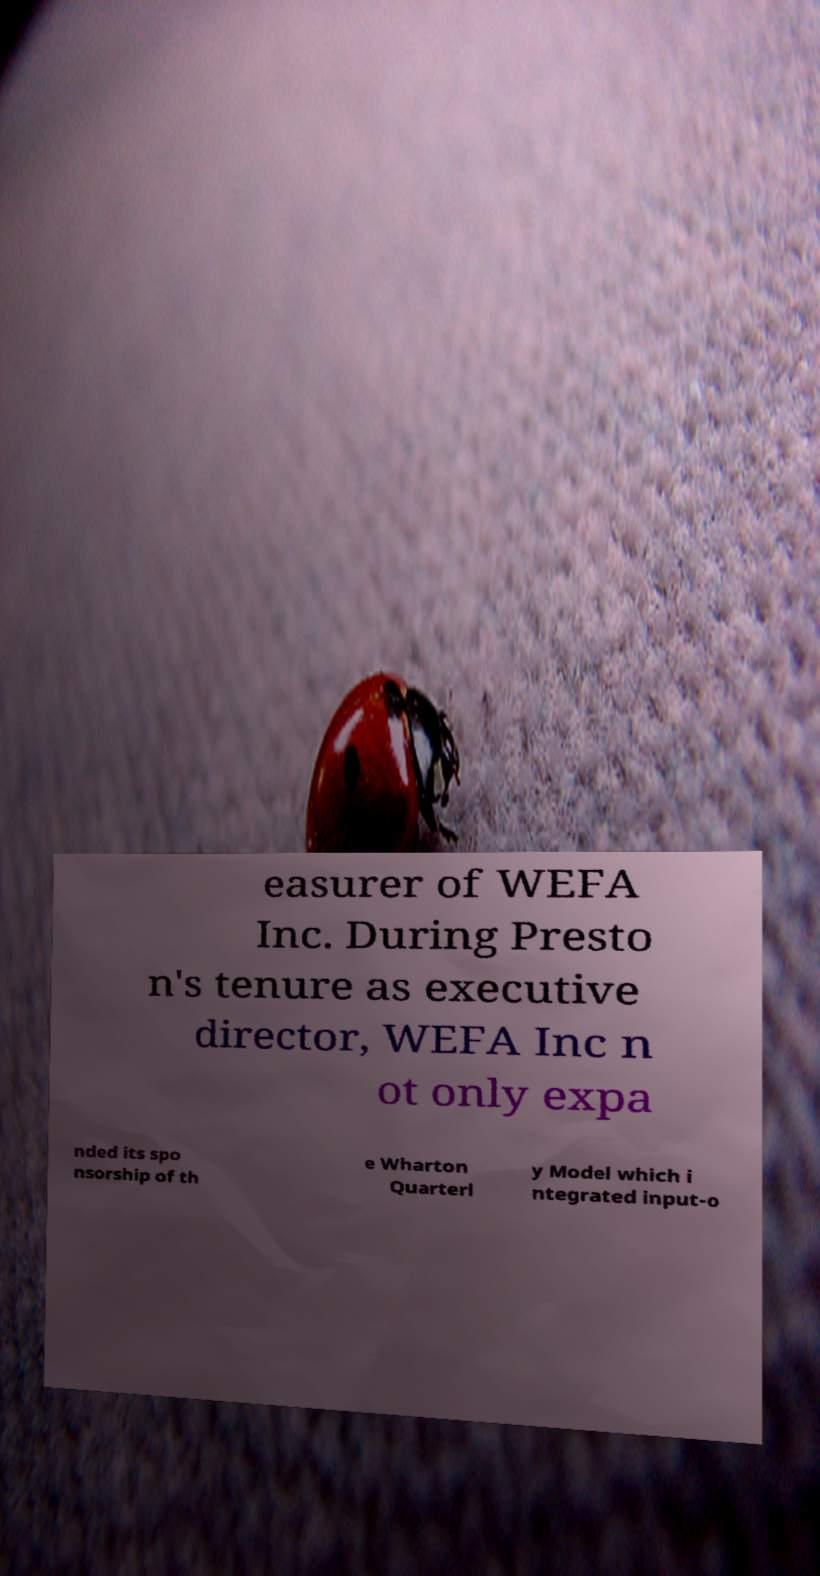I need the written content from this picture converted into text. Can you do that? easurer of WEFA Inc. During Presto n's tenure as executive director, WEFA Inc n ot only expa nded its spo nsorship of th e Wharton Quarterl y Model which i ntegrated input-o 